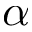Convert formula to latex. <formula><loc_0><loc_0><loc_500><loc_500>\alpha</formula> 